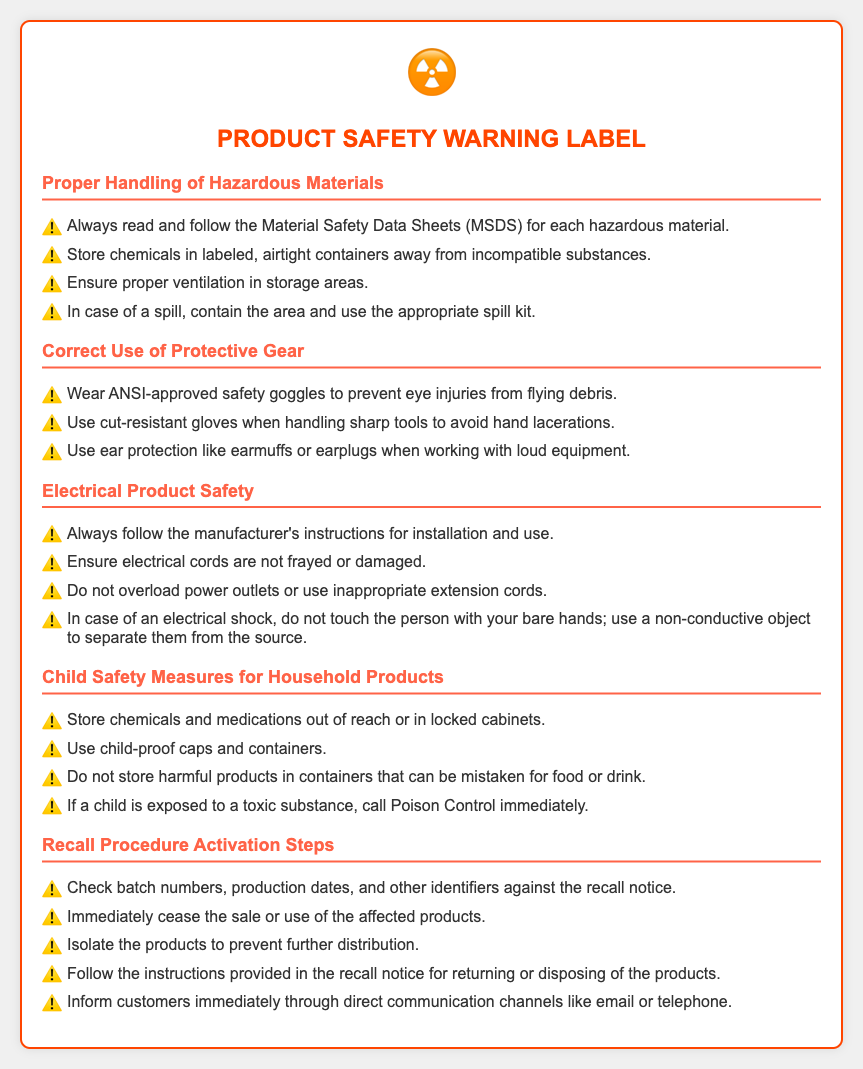What should you always read for hazardous materials? The document states you should always read the Material Safety Data Sheets (MSDS) for each hazardous material.
Answer: Material Safety Data Sheets (MSDS) What should be used when handling sharp tools? It is mentioned that cut-resistant gloves should be used to avoid hand lacerations when handling sharp tools.
Answer: Cut-resistant gloves What precaution should be taken to prevent electrical shocks? The document advises not to touch a person experiencing an electrical shock with your bare hands and instead use a non-conductive object to separate them from the source.
Answer: Non-conductive object How should chemicals be stored to protect children? The guideline suggests that chemicals should be stored out of reach or in locked cabinets to protect children.
Answer: Out of reach or in locked cabinets What is the first step when activating a recall procedure? It is stated that you should check batch numbers, production dates, and other identifiers against the recall notice as the first step when activating a recall procedure.
Answer: Check batch numbers What type of safety gear is recommended for eye protection? The document recommends wearing ANSI-approved safety goggles to prevent eye injuries.
Answer: ANSI-approved safety goggles What should be done immediately after a product recall notice? It is indicated that the sale or use of the affected products should be ceased immediately after a product recall notice.
Answer: Cease sale or use Which type of caps should be used for household products to enhance child safety? The document suggests using child-proof caps and containers to enhance child safety.
Answer: Child-proof caps What kind of cords should not be used for electrical products? The document specifies not to use frayed or damaged electrical cords as they pose hazards.
Answer: Frayed or damaged cords 